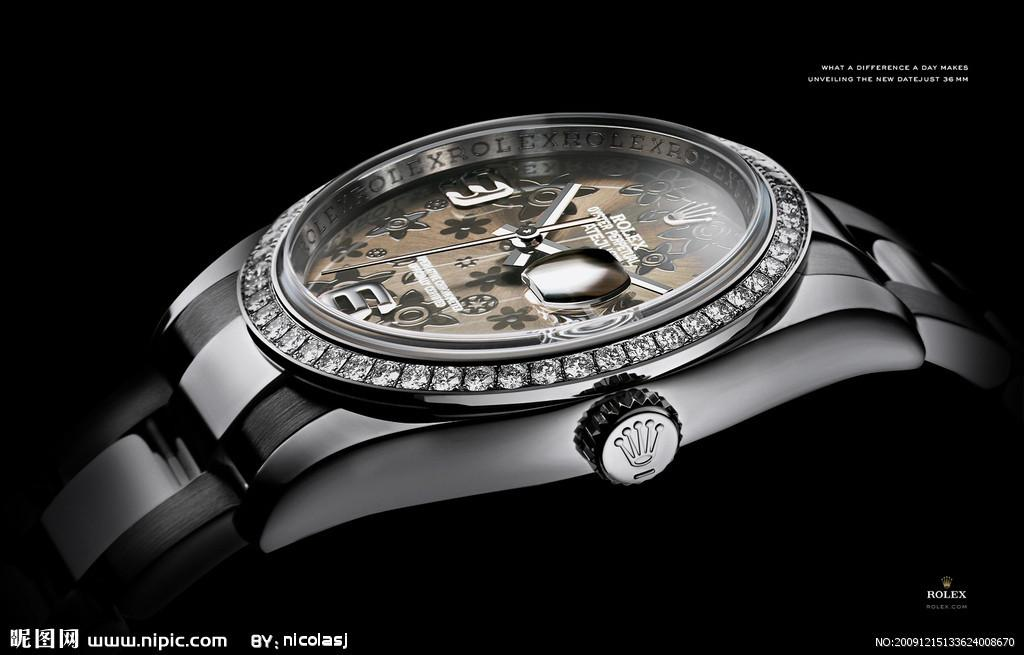<image>
Present a compact description of the photo's key features. The side of a Rolex watch is lined with diamonds. 